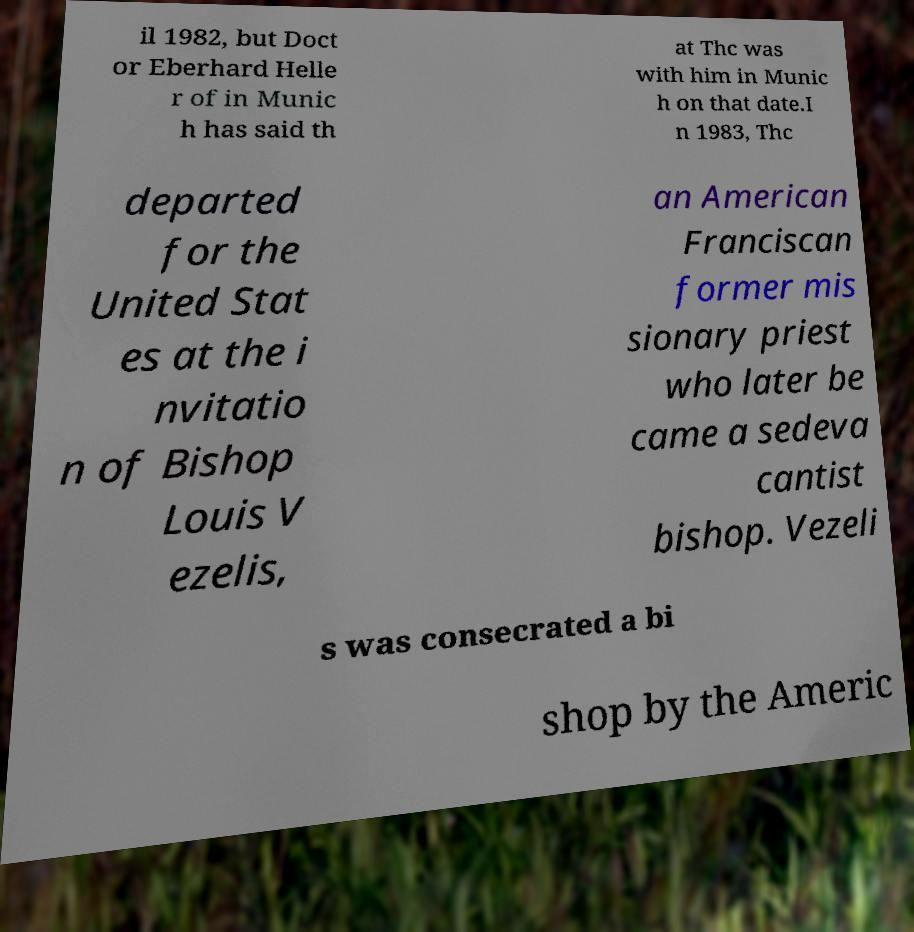Please read and relay the text visible in this image. What does it say? il 1982, but Doct or Eberhard Helle r of in Munic h has said th at Thc was with him in Munic h on that date.I n 1983, Thc departed for the United Stat es at the i nvitatio n of Bishop Louis V ezelis, an American Franciscan former mis sionary priest who later be came a sedeva cantist bishop. Vezeli s was consecrated a bi shop by the Americ 